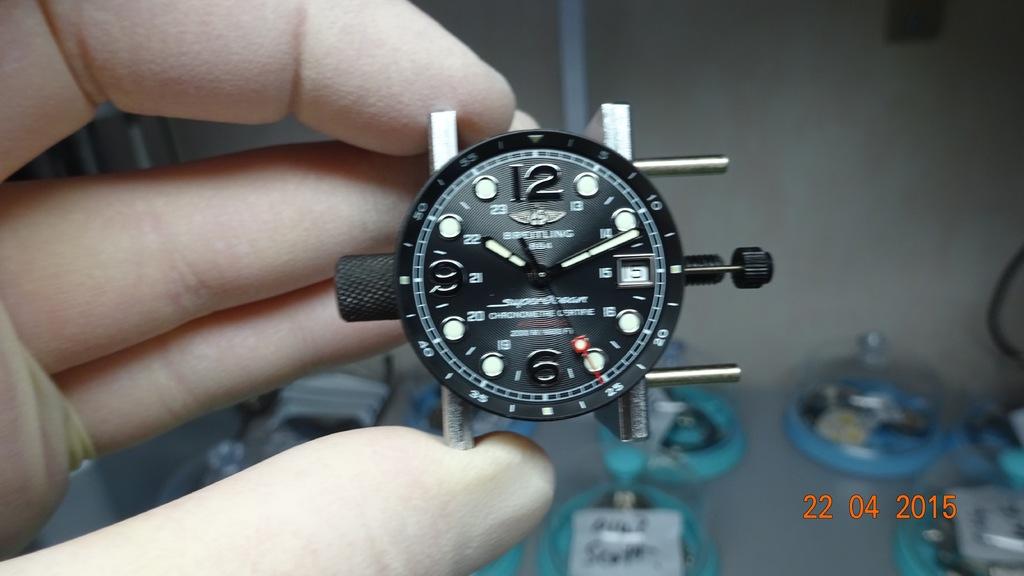What is the date on the time stamp?
Your answer should be very brief. 22 04 2015. What is the brand of watch shown here?
Give a very brief answer. Breitling. 